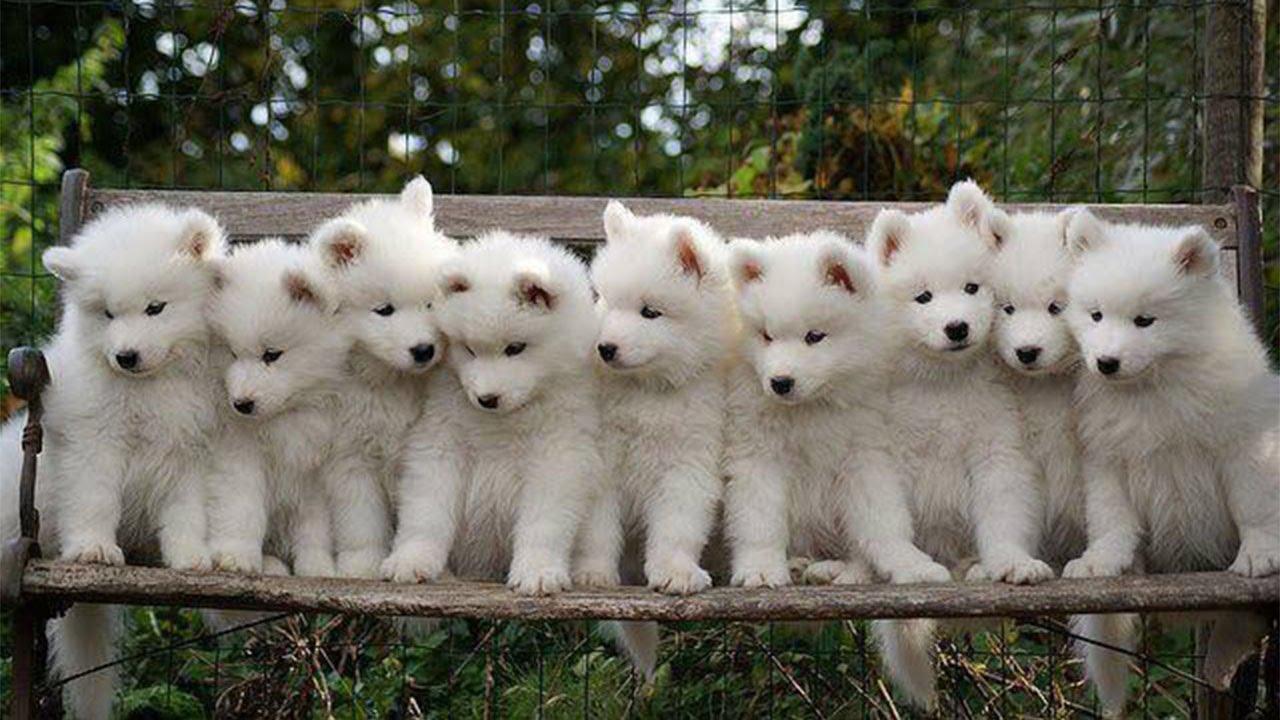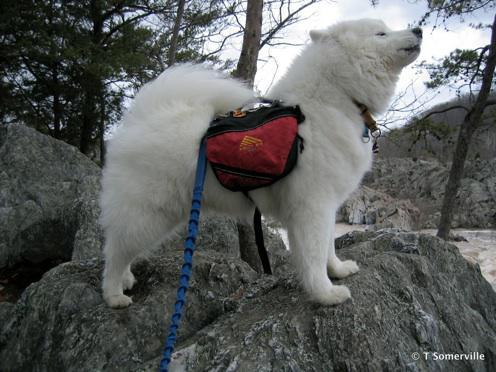The first image is the image on the left, the second image is the image on the right. Given the left and right images, does the statement "An image shows a rightward facing dog wearing a pack." hold true? Answer yes or no. Yes. The first image is the image on the left, the second image is the image on the right. Given the left and right images, does the statement "A white dog has a colored canvas bag strapped to its back in one image, while the other image is of multiple dogs with no bags." hold true? Answer yes or no. Yes. 